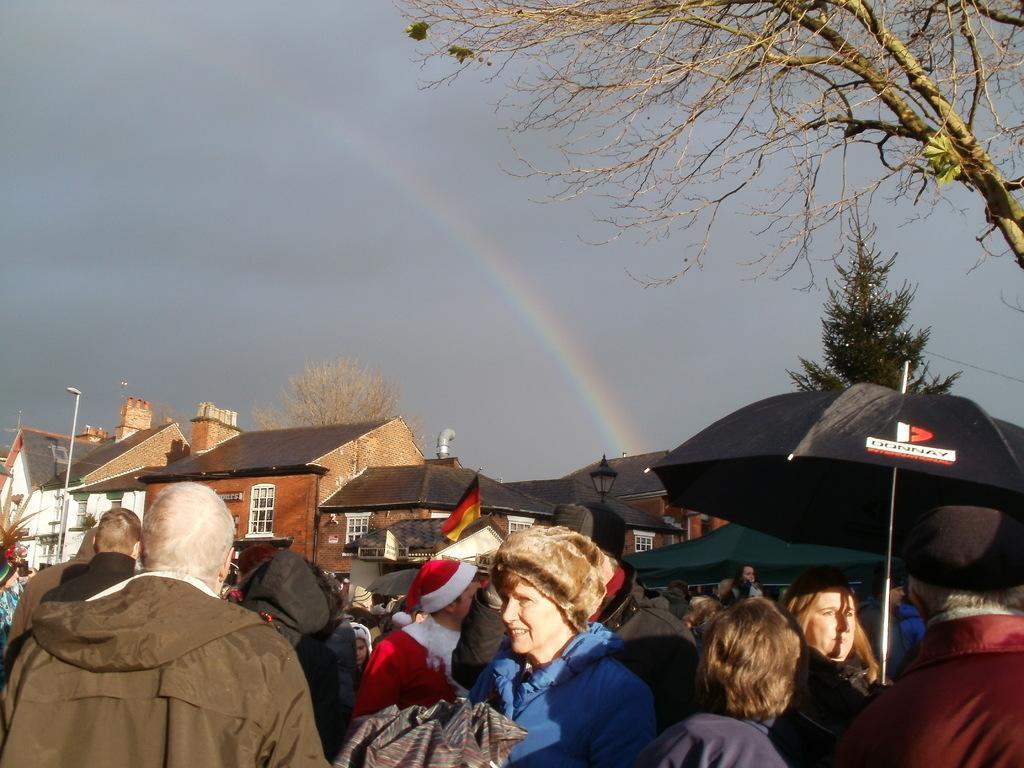Could you give a brief overview of what you see in this image? At the bottom of the image there are people. In the background of the image there are houses There is sky and rainbow. To the right side of the image there are trees. 